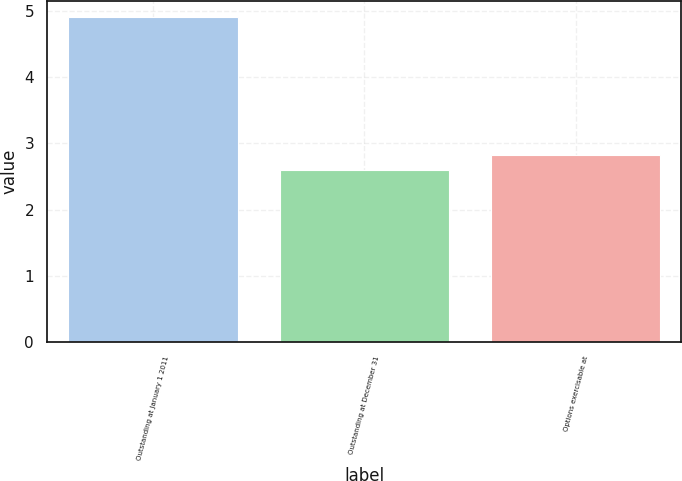Convert chart to OTSL. <chart><loc_0><loc_0><loc_500><loc_500><bar_chart><fcel>Outstanding at January 1 2011<fcel>Outstanding at December 31<fcel>Options exercisable at<nl><fcel>4.9<fcel>2.6<fcel>2.83<nl></chart> 